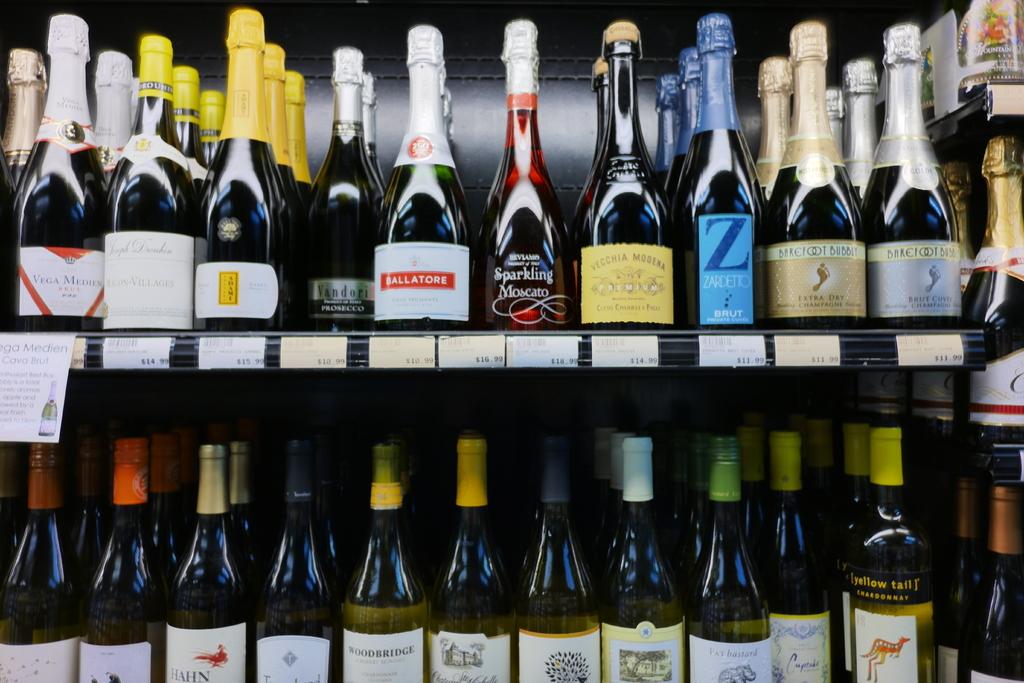What is the price of the bottle with the blue label?
Offer a terse response. 11.99. 